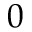Convert formula to latex. <formula><loc_0><loc_0><loc_500><loc_500>0</formula> 